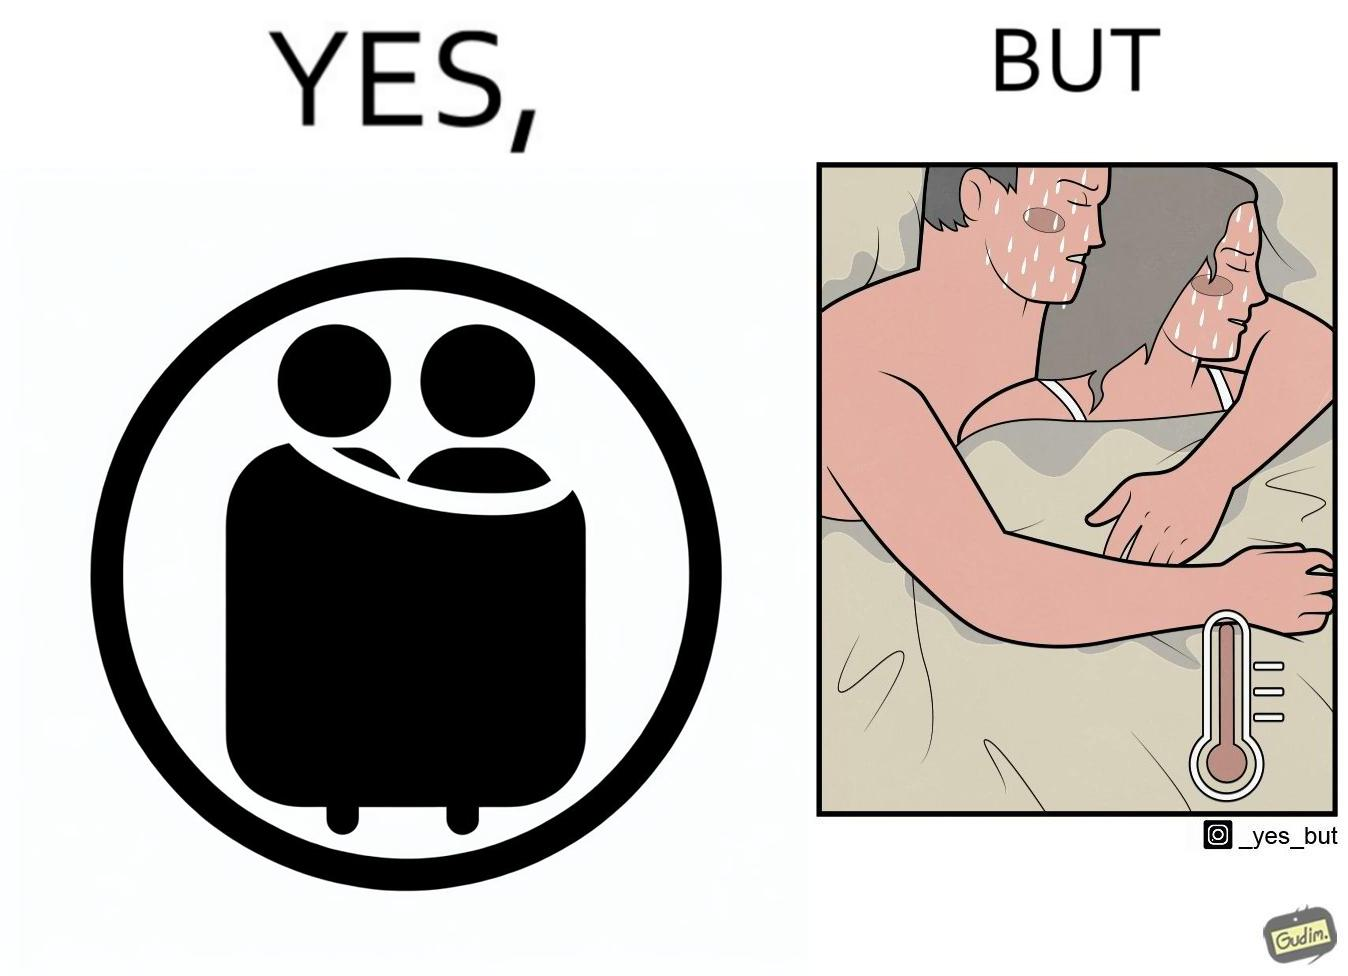Is this a satirical image? Yes, this image is satirical. 